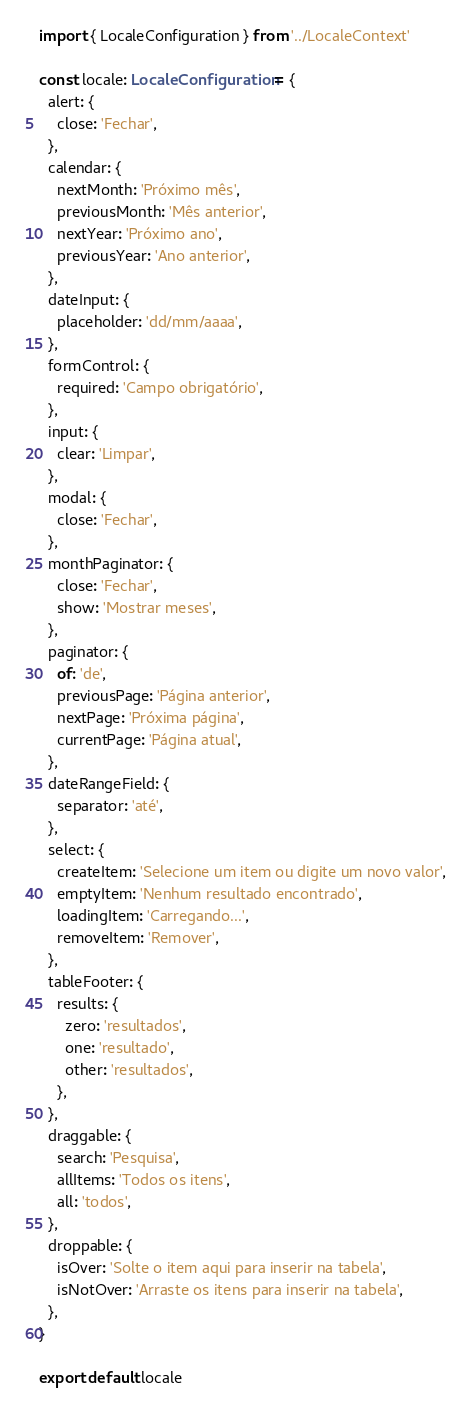<code> <loc_0><loc_0><loc_500><loc_500><_TypeScript_>import { LocaleConfiguration } from '../LocaleContext'

const locale: LocaleConfiguration = {
  alert: {
    close: 'Fechar',
  },
  calendar: {
    nextMonth: 'Próximo mês',
    previousMonth: 'Mês anterior',
    nextYear: 'Próximo ano',
    previousYear: 'Ano anterior',
  },
  dateInput: {
    placeholder: 'dd/mm/aaaa',
  },
  formControl: {
    required: 'Campo obrigatório',
  },
  input: {
    clear: 'Limpar',
  },
  modal: {
    close: 'Fechar',
  },
  monthPaginator: {
    close: 'Fechar',
    show: 'Mostrar meses',
  },
  paginator: {
    of: 'de',
    previousPage: 'Página anterior',
    nextPage: 'Próxima página',
    currentPage: 'Página atual',
  },
  dateRangeField: {
    separator: 'até',
  },
  select: {
    createItem: 'Selecione um item ou digite um novo valor',
    emptyItem: 'Nenhum resultado encontrado',
    loadingItem: 'Carregando...',
    removeItem: 'Remover',
  },
  tableFooter: {
    results: {
      zero: 'resultados',
      one: 'resultado',
      other: 'resultados',
    },
  },
  draggable: {
    search: 'Pesquisa',
    allItems: 'Todos os itens',
    all: 'todos',
  },
  droppable: {
    isOver: 'Solte o item aqui para inserir na tabela',
    isNotOver: 'Arraste os itens para inserir na tabela',
  },
}

export default locale
</code> 